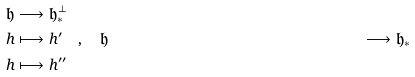<formula> <loc_0><loc_0><loc_500><loc_500>\mathfrak { h } & \longrightarrow \mathfrak { h } _ { * } ^ { \perp } \\ h & \longmapsto h ^ { \prime } \text {\quad , \quad} \mathfrak { h } & \longrightarrow \mathfrak { h } _ { * } \\ h & \longmapsto h ^ { \prime \prime }</formula> 